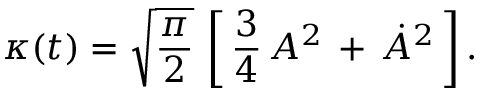Convert formula to latex. <formula><loc_0><loc_0><loc_500><loc_500>\kappa ( t ) = \sqrt { { \frac { \pi } { 2 } } } \, \left [ \, { \frac { 3 } { 4 } } \, A ^ { 2 } \, + \, \dot { A } ^ { 2 } \, \right ] .</formula> 